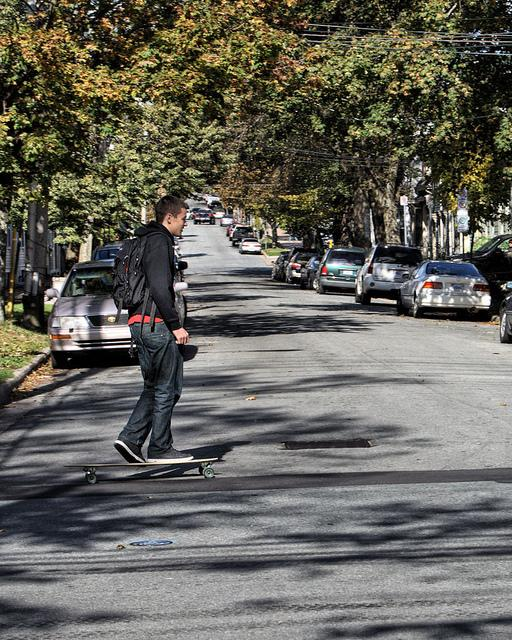What country does the white car originate from? Please explain your reasoning. japan. The country is japan. 